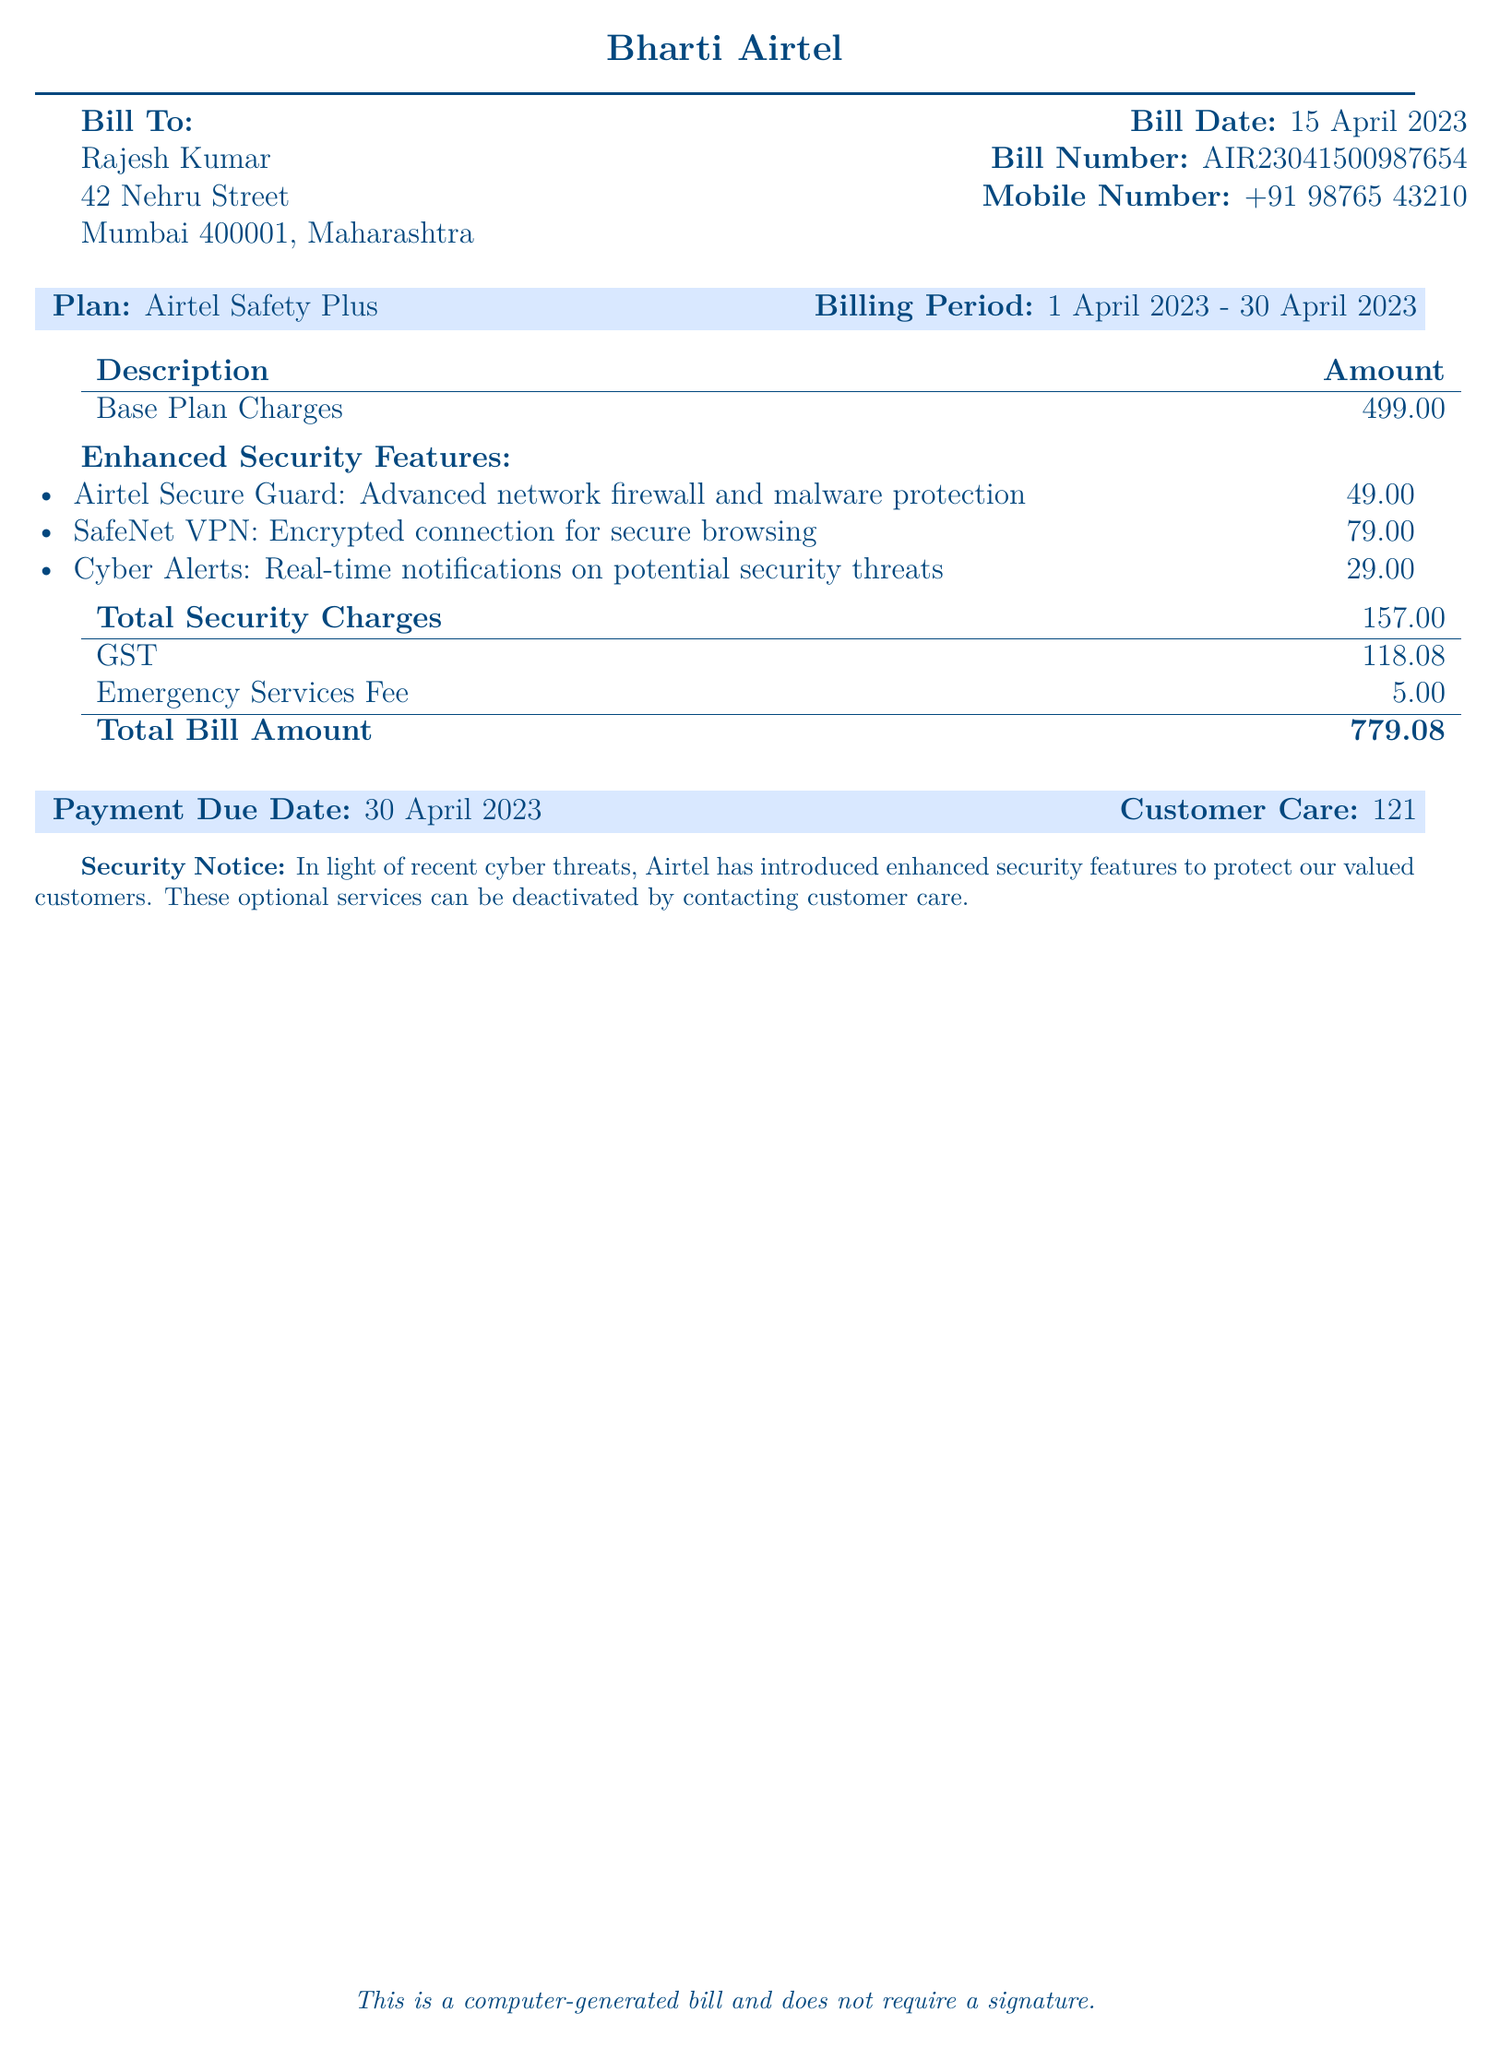What is the mobile number on the bill? The mobile number listed in the bill is located under the customer details section.
Answer: +91 98765 43210 What is the total bill amount? The total bill amount is calculated by adding the total charges and GST, which is indicated at the end of the document.
Answer: ₹779.08 When is the payment due date? The payment due date is found in the section that highlights important billing information.
Answer: 30 April 2023 What are the charges for Airtel Secure Guard? The charges for Airtel Secure Guard are detailed in the section for enhanced security features.
Answer: ₹49.00 What plan is being billed? The plan is mentioned at the top of the document under the billing details.
Answer: Airtel Safety Plus How much is the GST on the bill? The GST amount is specified in the financial summary section of the bill.
Answer: ₹118.08 What is the name of the customer? The customer's name is located in the billing information section at the beginning of the document.
Answer: Rajesh Kumar What feature offers real-time notifications on potential security threats? This feature is described in the list of enhanced security features included in the bill.
Answer: Cyber Alerts What is the total security charges? The total security charges are summed up from the individual enhanced security features listed in the document.
Answer: ₹157.00 